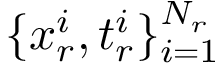Convert formula to latex. <formula><loc_0><loc_0><loc_500><loc_500>\{ x _ { r } ^ { i } , t _ { r } ^ { i } \} _ { i = 1 } ^ { N _ { r } }</formula> 